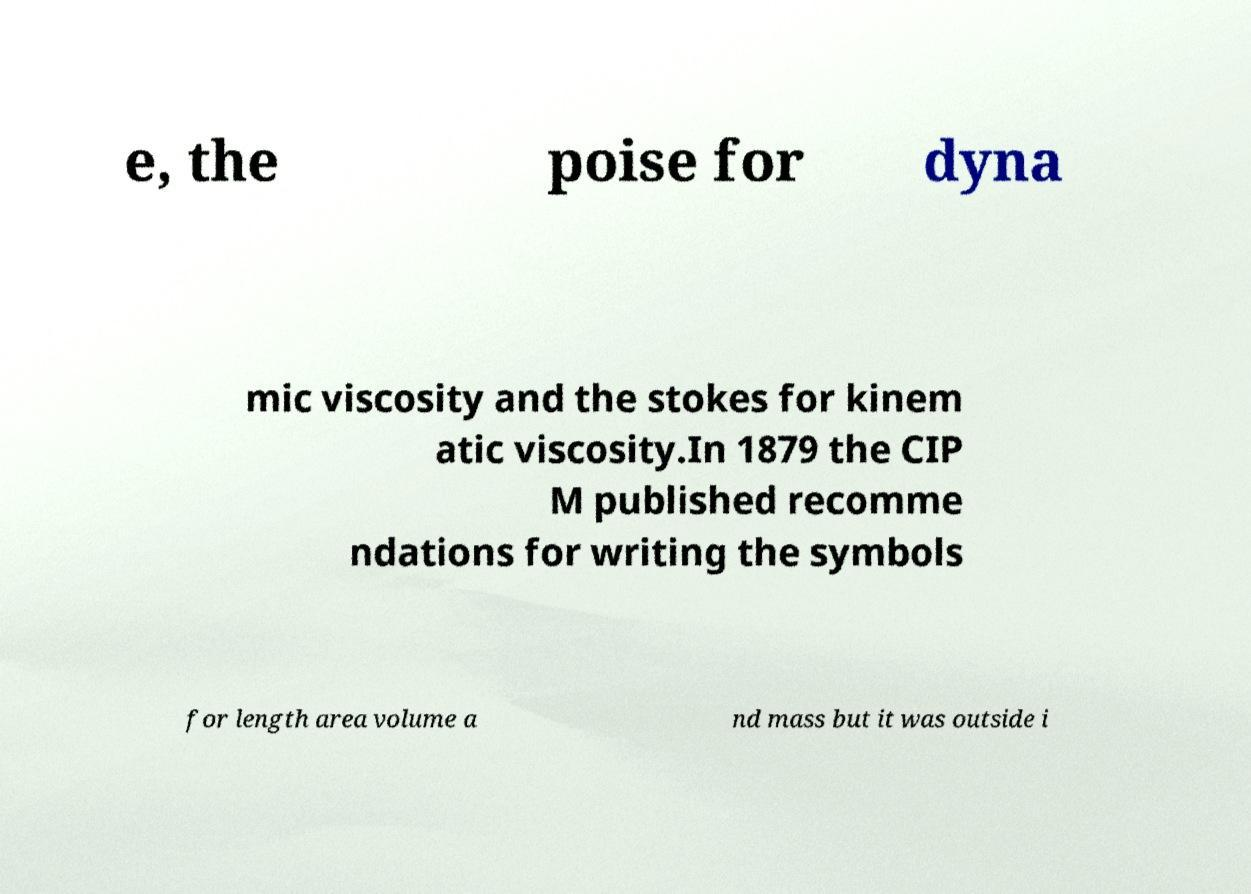What messages or text are displayed in this image? I need them in a readable, typed format. e, the poise for dyna mic viscosity and the stokes for kinem atic viscosity.In 1879 the CIP M published recomme ndations for writing the symbols for length area volume a nd mass but it was outside i 